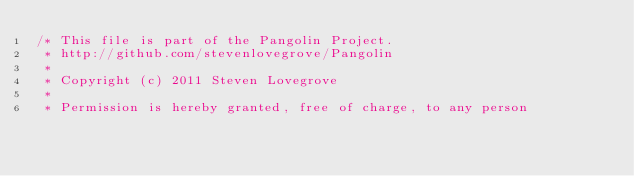<code> <loc_0><loc_0><loc_500><loc_500><_C_>/* This file is part of the Pangolin Project.
 * http://github.com/stevenlovegrove/Pangolin
 *
 * Copyright (c) 2011 Steven Lovegrove
 *
 * Permission is hereby granted, free of charge, to any person</code> 